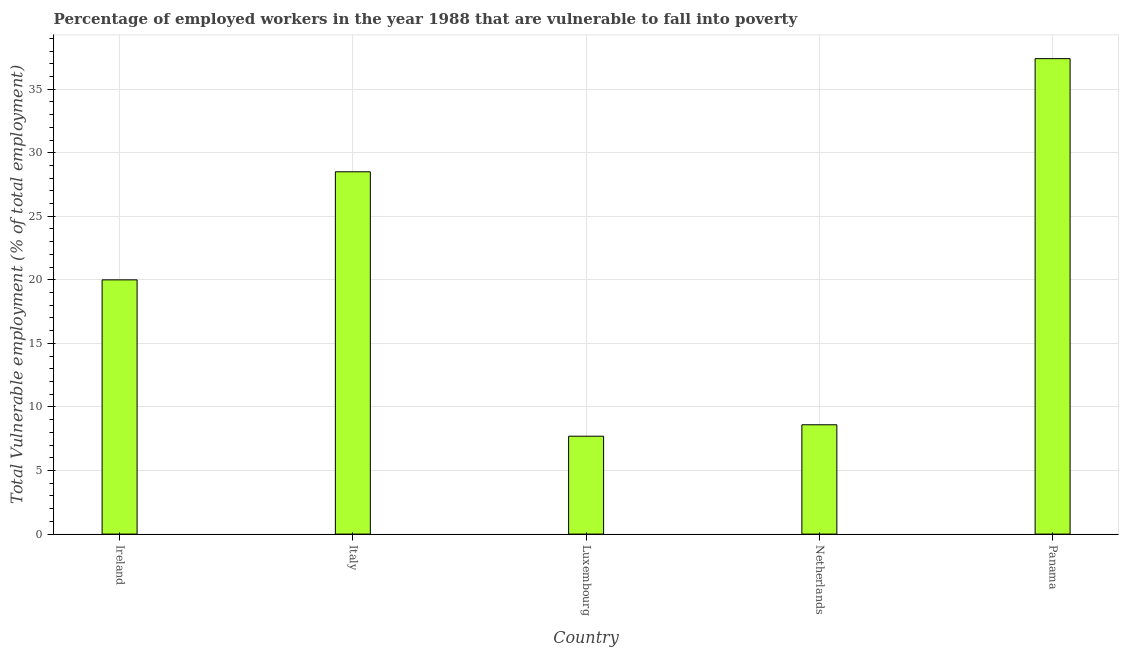Does the graph contain any zero values?
Your answer should be compact. No. Does the graph contain grids?
Ensure brevity in your answer.  Yes. What is the title of the graph?
Your answer should be very brief. Percentage of employed workers in the year 1988 that are vulnerable to fall into poverty. What is the label or title of the X-axis?
Your answer should be very brief. Country. What is the label or title of the Y-axis?
Your response must be concise. Total Vulnerable employment (% of total employment). What is the total vulnerable employment in Luxembourg?
Your response must be concise. 7.7. Across all countries, what is the maximum total vulnerable employment?
Your answer should be very brief. 37.4. Across all countries, what is the minimum total vulnerable employment?
Your answer should be very brief. 7.7. In which country was the total vulnerable employment maximum?
Offer a terse response. Panama. In which country was the total vulnerable employment minimum?
Your answer should be compact. Luxembourg. What is the sum of the total vulnerable employment?
Make the answer very short. 102.2. What is the average total vulnerable employment per country?
Your answer should be compact. 20.44. What is the median total vulnerable employment?
Offer a terse response. 20. What is the ratio of the total vulnerable employment in Italy to that in Luxembourg?
Offer a very short reply. 3.7. What is the difference between the highest and the second highest total vulnerable employment?
Your answer should be very brief. 8.9. What is the difference between the highest and the lowest total vulnerable employment?
Make the answer very short. 29.7. How many bars are there?
Provide a succinct answer. 5. Are all the bars in the graph horizontal?
Provide a short and direct response. No. What is the difference between two consecutive major ticks on the Y-axis?
Offer a terse response. 5. What is the Total Vulnerable employment (% of total employment) of Ireland?
Your response must be concise. 20. What is the Total Vulnerable employment (% of total employment) of Italy?
Make the answer very short. 28.5. What is the Total Vulnerable employment (% of total employment) of Luxembourg?
Your response must be concise. 7.7. What is the Total Vulnerable employment (% of total employment) of Netherlands?
Provide a short and direct response. 8.6. What is the Total Vulnerable employment (% of total employment) of Panama?
Ensure brevity in your answer.  37.4. What is the difference between the Total Vulnerable employment (% of total employment) in Ireland and Italy?
Ensure brevity in your answer.  -8.5. What is the difference between the Total Vulnerable employment (% of total employment) in Ireland and Luxembourg?
Your response must be concise. 12.3. What is the difference between the Total Vulnerable employment (% of total employment) in Ireland and Panama?
Your answer should be compact. -17.4. What is the difference between the Total Vulnerable employment (% of total employment) in Italy and Luxembourg?
Keep it short and to the point. 20.8. What is the difference between the Total Vulnerable employment (% of total employment) in Italy and Panama?
Offer a very short reply. -8.9. What is the difference between the Total Vulnerable employment (% of total employment) in Luxembourg and Panama?
Make the answer very short. -29.7. What is the difference between the Total Vulnerable employment (% of total employment) in Netherlands and Panama?
Make the answer very short. -28.8. What is the ratio of the Total Vulnerable employment (% of total employment) in Ireland to that in Italy?
Ensure brevity in your answer.  0.7. What is the ratio of the Total Vulnerable employment (% of total employment) in Ireland to that in Luxembourg?
Provide a short and direct response. 2.6. What is the ratio of the Total Vulnerable employment (% of total employment) in Ireland to that in Netherlands?
Your answer should be very brief. 2.33. What is the ratio of the Total Vulnerable employment (% of total employment) in Ireland to that in Panama?
Provide a short and direct response. 0.54. What is the ratio of the Total Vulnerable employment (% of total employment) in Italy to that in Luxembourg?
Your answer should be compact. 3.7. What is the ratio of the Total Vulnerable employment (% of total employment) in Italy to that in Netherlands?
Give a very brief answer. 3.31. What is the ratio of the Total Vulnerable employment (% of total employment) in Italy to that in Panama?
Make the answer very short. 0.76. What is the ratio of the Total Vulnerable employment (% of total employment) in Luxembourg to that in Netherlands?
Keep it short and to the point. 0.9. What is the ratio of the Total Vulnerable employment (% of total employment) in Luxembourg to that in Panama?
Your answer should be compact. 0.21. What is the ratio of the Total Vulnerable employment (% of total employment) in Netherlands to that in Panama?
Offer a terse response. 0.23. 